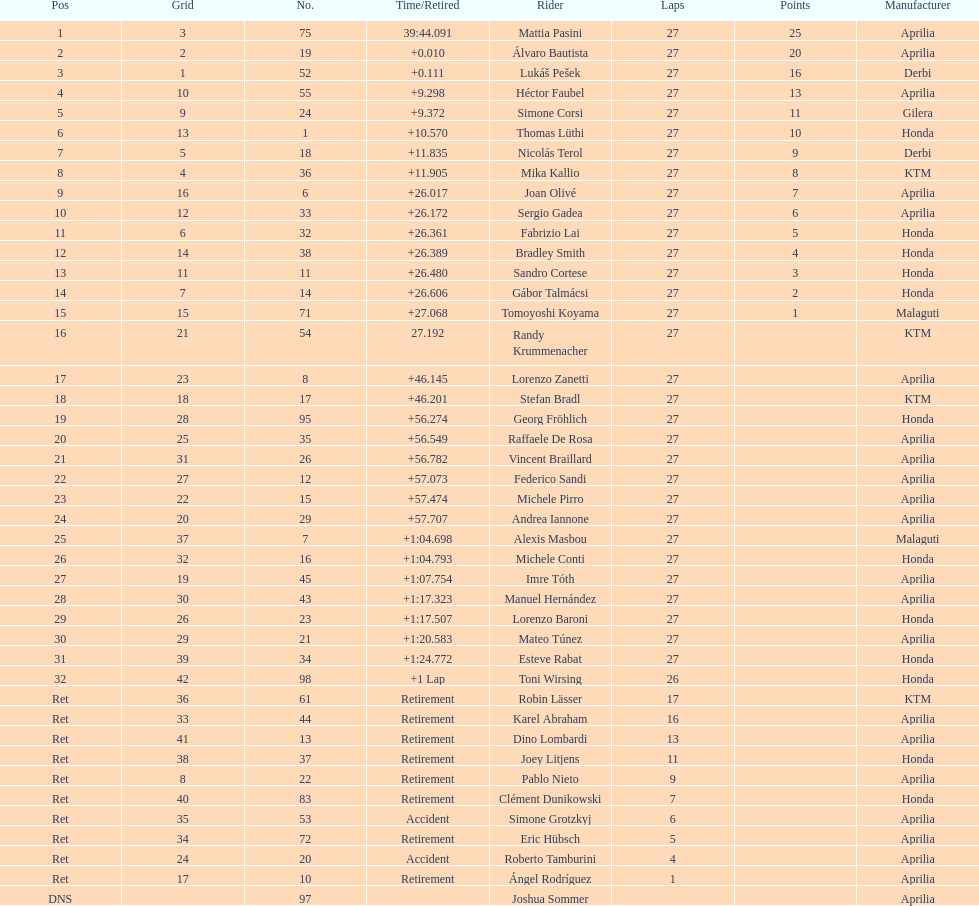Who placed higher, bradl or gadea? Sergio Gadea. 